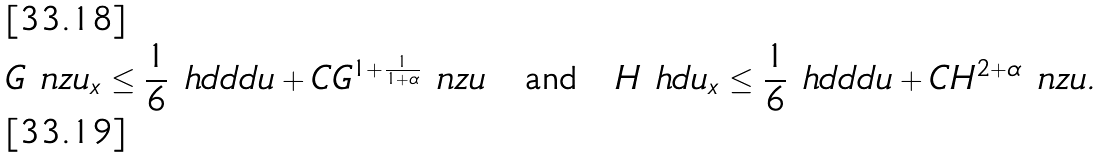<formula> <loc_0><loc_0><loc_500><loc_500>G \ n z { u _ { x } } & \leq \frac { 1 } { 6 } \ h d d d { u } + C G ^ { 1 + \frac { 1 } { 1 + \alpha } } \ n z { u } \quad \text {and} \quad H \ h d { u _ { x } } \leq \frac { 1 } { 6 } \ h d d d { u } + C H ^ { 2 + \alpha } \ n z { u } . \\</formula> 